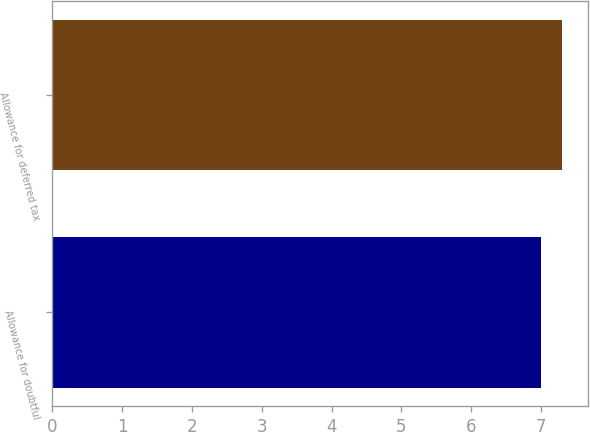Convert chart. <chart><loc_0><loc_0><loc_500><loc_500><bar_chart><fcel>Allowance for doubtful<fcel>Allowance for deferred tax<nl><fcel>7<fcel>7.3<nl></chart> 